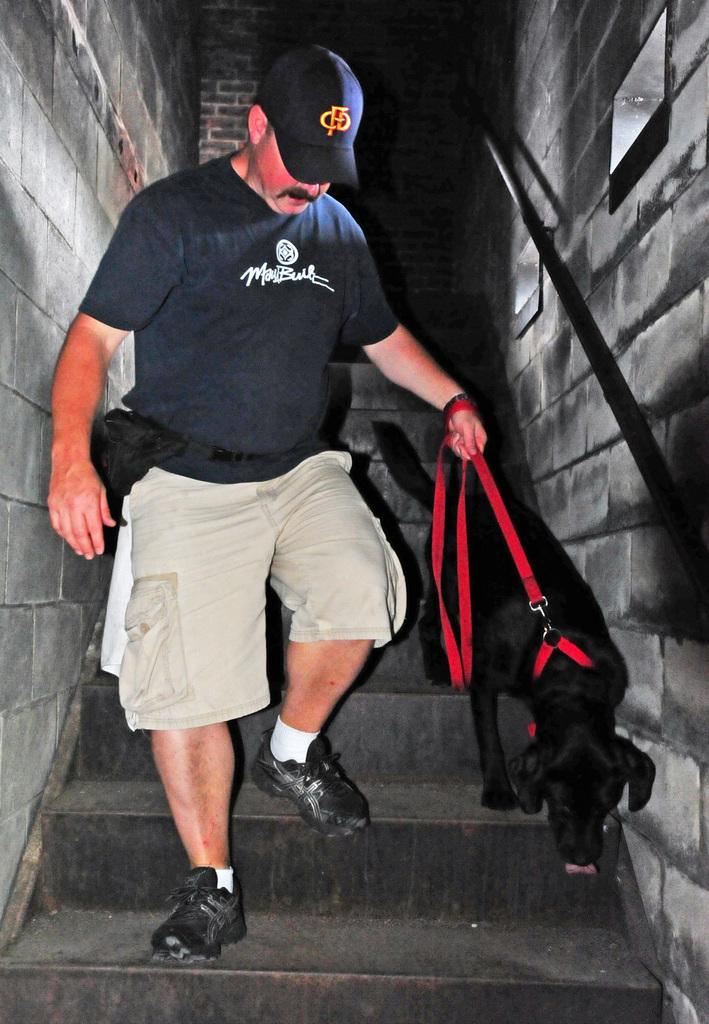What is the main subject of the image? There is a person in the image. What is the person wearing? The person is wearing a black shirt. What action is the person performing? The person is climbing down the steps. What object is the person holding? The person is holding a belt. What is the belt connected to? The belt is tightened to a dog. What type of gate can be seen in the image? There is no gate present in the image. Is there a church visible in the image? There is no church present in the image. 